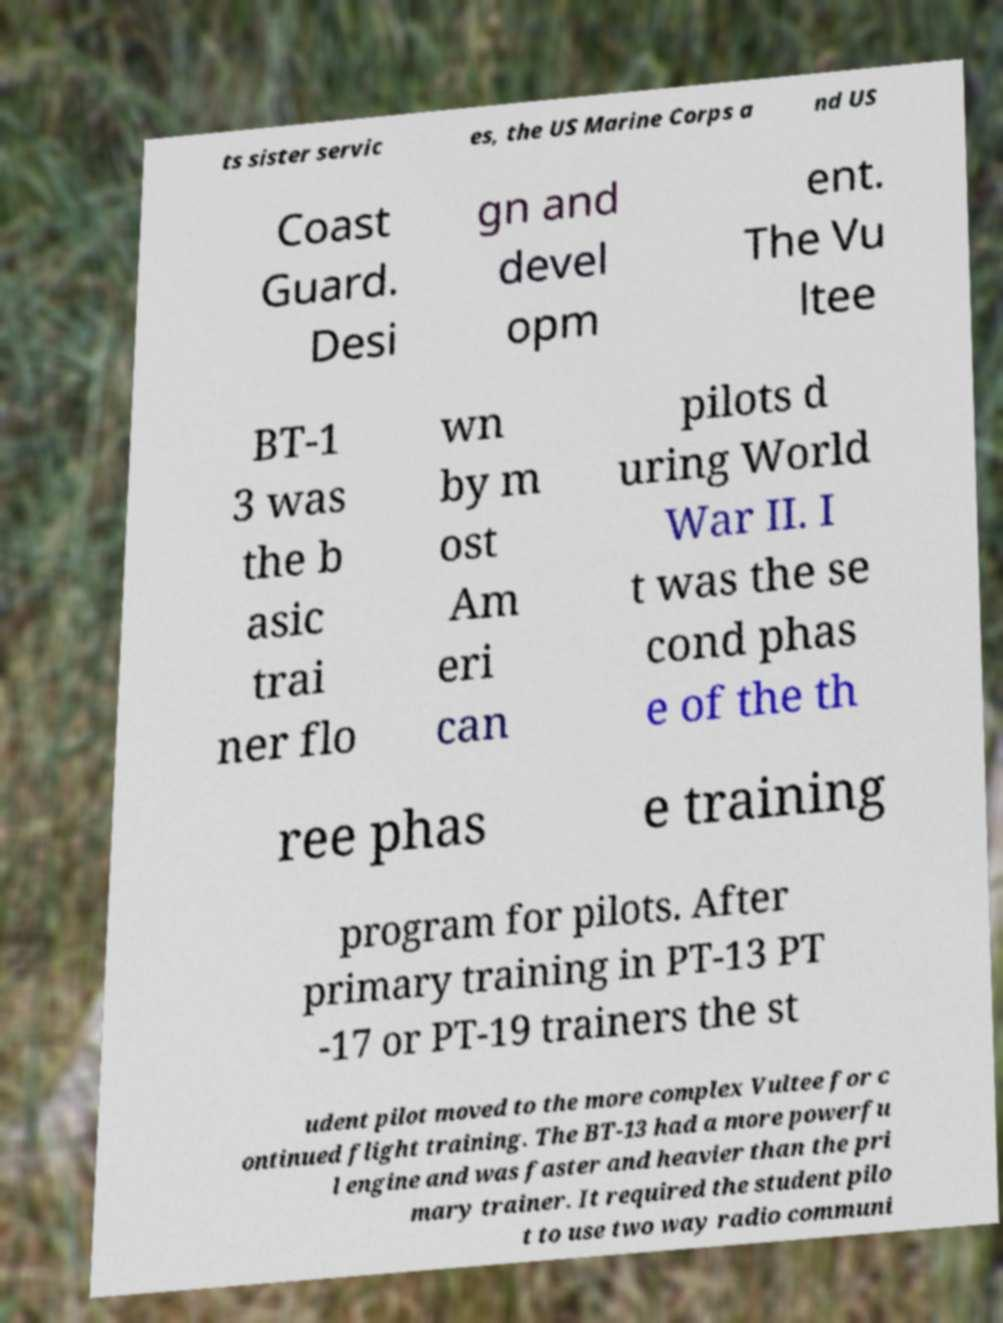Can you read and provide the text displayed in the image?This photo seems to have some interesting text. Can you extract and type it out for me? ts sister servic es, the US Marine Corps a nd US Coast Guard. Desi gn and devel opm ent. The Vu ltee BT-1 3 was the b asic trai ner flo wn by m ost Am eri can pilots d uring World War II. I t was the se cond phas e of the th ree phas e training program for pilots. After primary training in PT-13 PT -17 or PT-19 trainers the st udent pilot moved to the more complex Vultee for c ontinued flight training. The BT-13 had a more powerfu l engine and was faster and heavier than the pri mary trainer. It required the student pilo t to use two way radio communi 